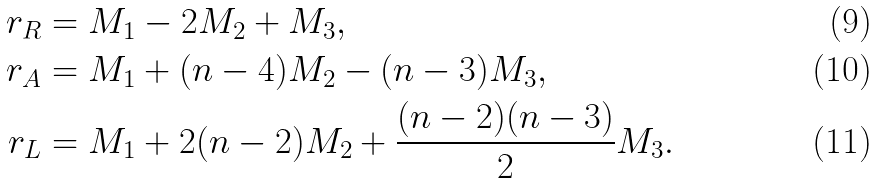<formula> <loc_0><loc_0><loc_500><loc_500>r _ { R } & = M _ { 1 } - 2 M _ { 2 } + M _ { 3 } , \\ r _ { A } & = M _ { 1 } + ( n - 4 ) M _ { 2 } - ( n - 3 ) M _ { 3 } , \\ r _ { L } & = M _ { 1 } + 2 ( n - 2 ) M _ { 2 } + \frac { ( n - 2 ) ( n - 3 ) } { 2 } M _ { 3 } .</formula> 